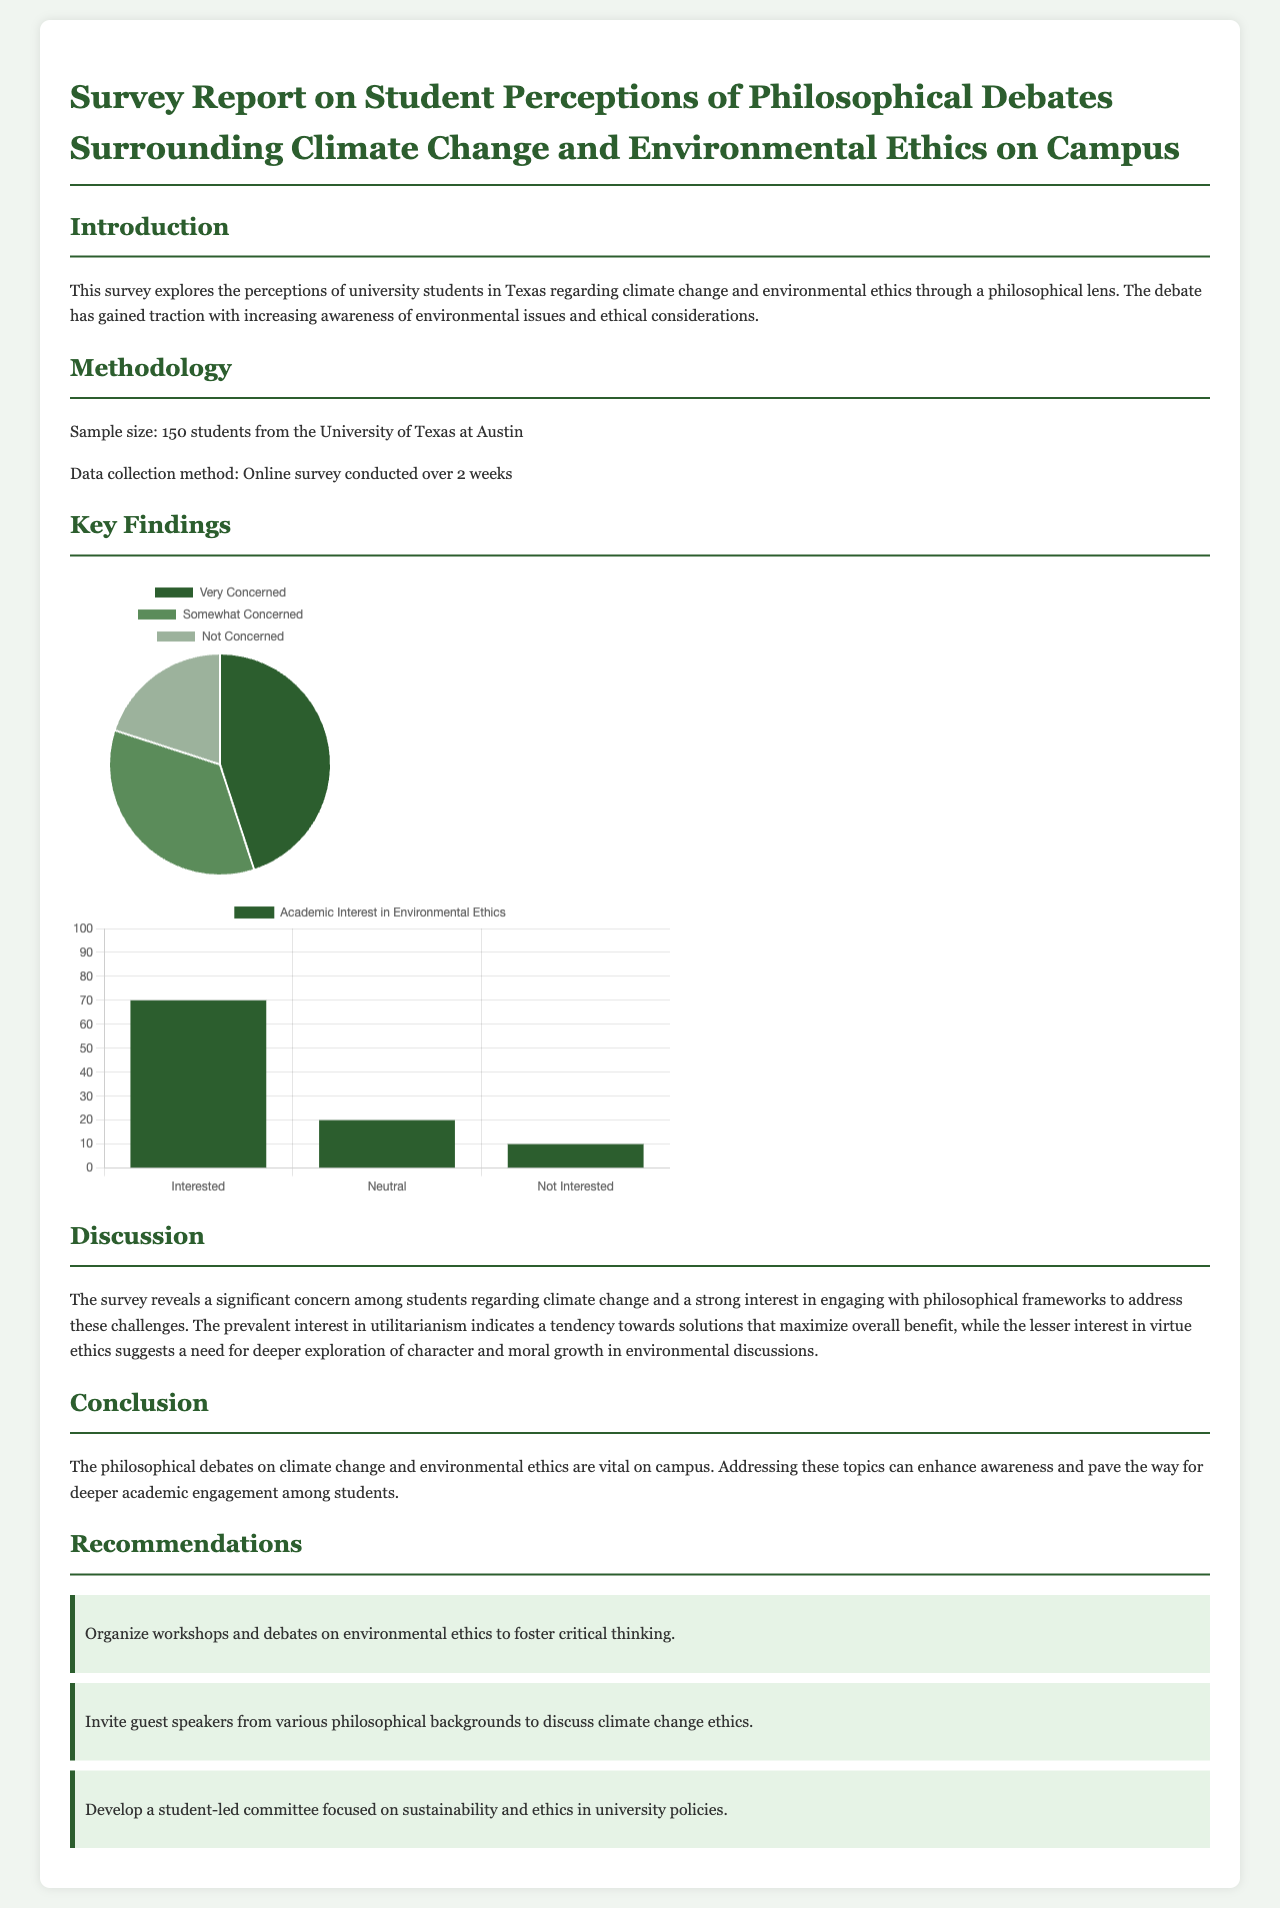What is the sample size of the survey? The sample size is specified in the methodology section of the report, indicating the number of students surveyed.
Answer: 150 students What percentage of students feel "Very Concerned" about climate change? This information is found in the perception chart, representing the proportions of students' concerns.
Answer: 45% What is the main academic interest area indicated by students? The discussion section highlights a specific philosophical framework that students showed interest in regarding climate change.
Answer: Utilitarianism How many weeks did the data collection take? The methodology section states the duration for which the online survey was conducted.
Answer: 2 weeks What percentage of students are "Not Interested" in environmental ethics? The academic interest chart provides this percentage, showing the level of disinterest among the surveyed students.
Answer: 10% What recommendation involves guest speakers? One of the recommendations specifically mentions the action to include guest speakers in order to enhance discussions on a particular ethical topic.
Answer: Invite guest speakers What philosophical approach has lesser interest according to the students? The discussion about different philosophical frameworks indicates a specific one that has less student interest, which signifies an area for deeper exploration.
Answer: Virtue ethics What is the overall focus of the report? The introduction outlines the main subject of the survey, emphasizing its relation to students' perceptions and philosophical discussions.
Answer: Climate change and environmental ethics 